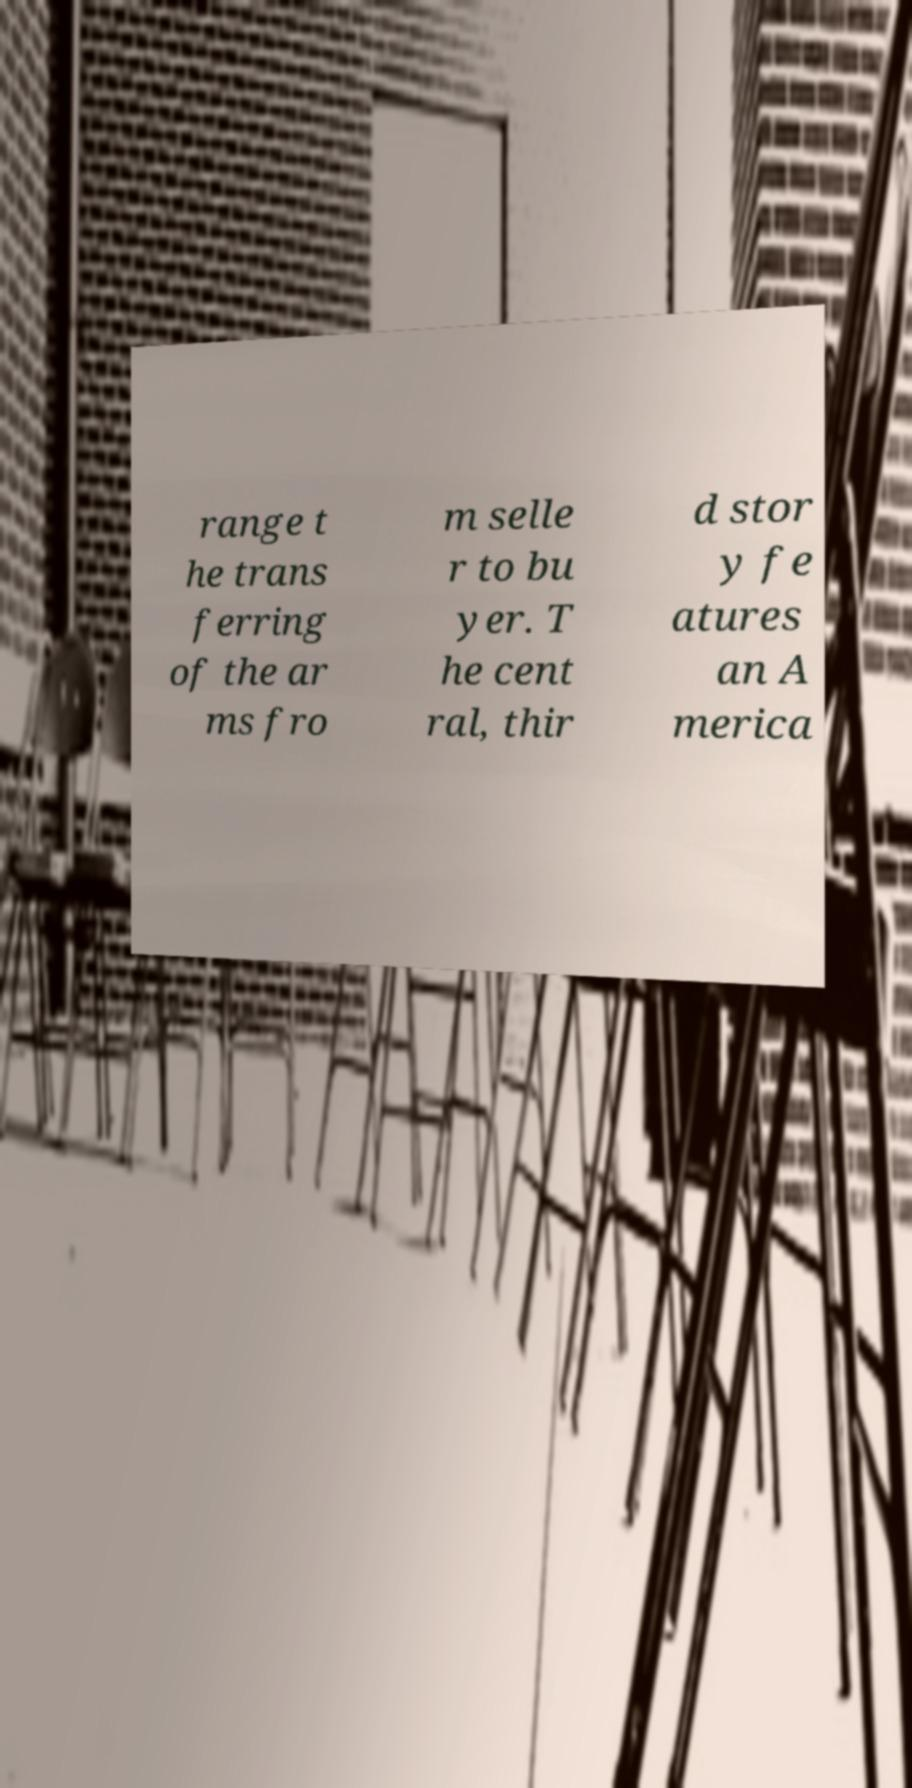There's text embedded in this image that I need extracted. Can you transcribe it verbatim? range t he trans ferring of the ar ms fro m selle r to bu yer. T he cent ral, thir d stor y fe atures an A merica 